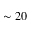Convert formula to latex. <formula><loc_0><loc_0><loc_500><loc_500>\sim 2 0</formula> 